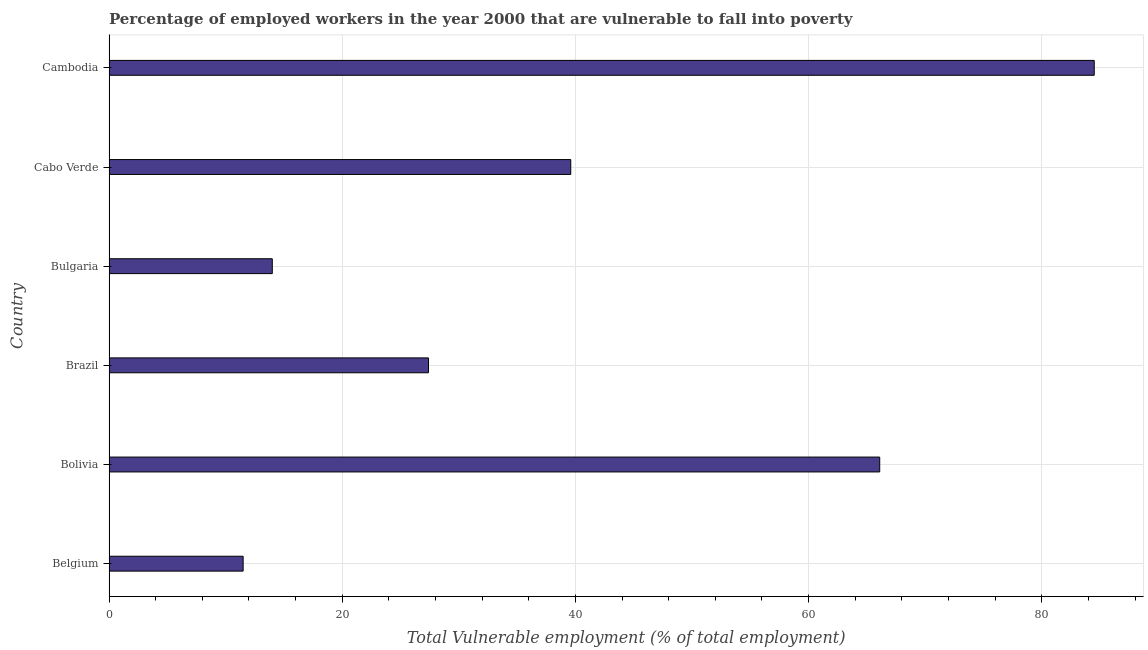Does the graph contain any zero values?
Provide a succinct answer. No. Does the graph contain grids?
Your response must be concise. Yes. What is the title of the graph?
Provide a succinct answer. Percentage of employed workers in the year 2000 that are vulnerable to fall into poverty. What is the label or title of the X-axis?
Keep it short and to the point. Total Vulnerable employment (% of total employment). What is the label or title of the Y-axis?
Offer a terse response. Country. What is the total vulnerable employment in Cabo Verde?
Keep it short and to the point. 39.6. Across all countries, what is the maximum total vulnerable employment?
Your answer should be compact. 84.5. In which country was the total vulnerable employment maximum?
Give a very brief answer. Cambodia. In which country was the total vulnerable employment minimum?
Provide a short and direct response. Belgium. What is the sum of the total vulnerable employment?
Keep it short and to the point. 243.1. What is the difference between the total vulnerable employment in Bolivia and Cabo Verde?
Offer a terse response. 26.5. What is the average total vulnerable employment per country?
Your answer should be very brief. 40.52. What is the median total vulnerable employment?
Provide a short and direct response. 33.5. What is the ratio of the total vulnerable employment in Brazil to that in Bulgaria?
Give a very brief answer. 1.96. Is the difference between the total vulnerable employment in Belgium and Bolivia greater than the difference between any two countries?
Make the answer very short. No. What is the difference between the highest and the second highest total vulnerable employment?
Make the answer very short. 18.4. What is the difference between the highest and the lowest total vulnerable employment?
Provide a succinct answer. 73. How many bars are there?
Provide a short and direct response. 6. What is the difference between two consecutive major ticks on the X-axis?
Make the answer very short. 20. Are the values on the major ticks of X-axis written in scientific E-notation?
Offer a terse response. No. What is the Total Vulnerable employment (% of total employment) in Belgium?
Provide a succinct answer. 11.5. What is the Total Vulnerable employment (% of total employment) of Bolivia?
Your answer should be compact. 66.1. What is the Total Vulnerable employment (% of total employment) in Brazil?
Offer a very short reply. 27.4. What is the Total Vulnerable employment (% of total employment) of Cabo Verde?
Provide a succinct answer. 39.6. What is the Total Vulnerable employment (% of total employment) of Cambodia?
Make the answer very short. 84.5. What is the difference between the Total Vulnerable employment (% of total employment) in Belgium and Bolivia?
Ensure brevity in your answer.  -54.6. What is the difference between the Total Vulnerable employment (% of total employment) in Belgium and Brazil?
Make the answer very short. -15.9. What is the difference between the Total Vulnerable employment (% of total employment) in Belgium and Cabo Verde?
Provide a succinct answer. -28.1. What is the difference between the Total Vulnerable employment (% of total employment) in Belgium and Cambodia?
Provide a short and direct response. -73. What is the difference between the Total Vulnerable employment (% of total employment) in Bolivia and Brazil?
Offer a very short reply. 38.7. What is the difference between the Total Vulnerable employment (% of total employment) in Bolivia and Bulgaria?
Your response must be concise. 52.1. What is the difference between the Total Vulnerable employment (% of total employment) in Bolivia and Cabo Verde?
Give a very brief answer. 26.5. What is the difference between the Total Vulnerable employment (% of total employment) in Bolivia and Cambodia?
Your answer should be very brief. -18.4. What is the difference between the Total Vulnerable employment (% of total employment) in Brazil and Cabo Verde?
Offer a very short reply. -12.2. What is the difference between the Total Vulnerable employment (% of total employment) in Brazil and Cambodia?
Your answer should be very brief. -57.1. What is the difference between the Total Vulnerable employment (% of total employment) in Bulgaria and Cabo Verde?
Your response must be concise. -25.6. What is the difference between the Total Vulnerable employment (% of total employment) in Bulgaria and Cambodia?
Your answer should be very brief. -70.5. What is the difference between the Total Vulnerable employment (% of total employment) in Cabo Verde and Cambodia?
Make the answer very short. -44.9. What is the ratio of the Total Vulnerable employment (% of total employment) in Belgium to that in Bolivia?
Offer a terse response. 0.17. What is the ratio of the Total Vulnerable employment (% of total employment) in Belgium to that in Brazil?
Your response must be concise. 0.42. What is the ratio of the Total Vulnerable employment (% of total employment) in Belgium to that in Bulgaria?
Ensure brevity in your answer.  0.82. What is the ratio of the Total Vulnerable employment (% of total employment) in Belgium to that in Cabo Verde?
Make the answer very short. 0.29. What is the ratio of the Total Vulnerable employment (% of total employment) in Belgium to that in Cambodia?
Keep it short and to the point. 0.14. What is the ratio of the Total Vulnerable employment (% of total employment) in Bolivia to that in Brazil?
Give a very brief answer. 2.41. What is the ratio of the Total Vulnerable employment (% of total employment) in Bolivia to that in Bulgaria?
Keep it short and to the point. 4.72. What is the ratio of the Total Vulnerable employment (% of total employment) in Bolivia to that in Cabo Verde?
Make the answer very short. 1.67. What is the ratio of the Total Vulnerable employment (% of total employment) in Bolivia to that in Cambodia?
Your answer should be compact. 0.78. What is the ratio of the Total Vulnerable employment (% of total employment) in Brazil to that in Bulgaria?
Your answer should be very brief. 1.96. What is the ratio of the Total Vulnerable employment (% of total employment) in Brazil to that in Cabo Verde?
Provide a short and direct response. 0.69. What is the ratio of the Total Vulnerable employment (% of total employment) in Brazil to that in Cambodia?
Make the answer very short. 0.32. What is the ratio of the Total Vulnerable employment (% of total employment) in Bulgaria to that in Cabo Verde?
Keep it short and to the point. 0.35. What is the ratio of the Total Vulnerable employment (% of total employment) in Bulgaria to that in Cambodia?
Ensure brevity in your answer.  0.17. What is the ratio of the Total Vulnerable employment (% of total employment) in Cabo Verde to that in Cambodia?
Provide a succinct answer. 0.47. 